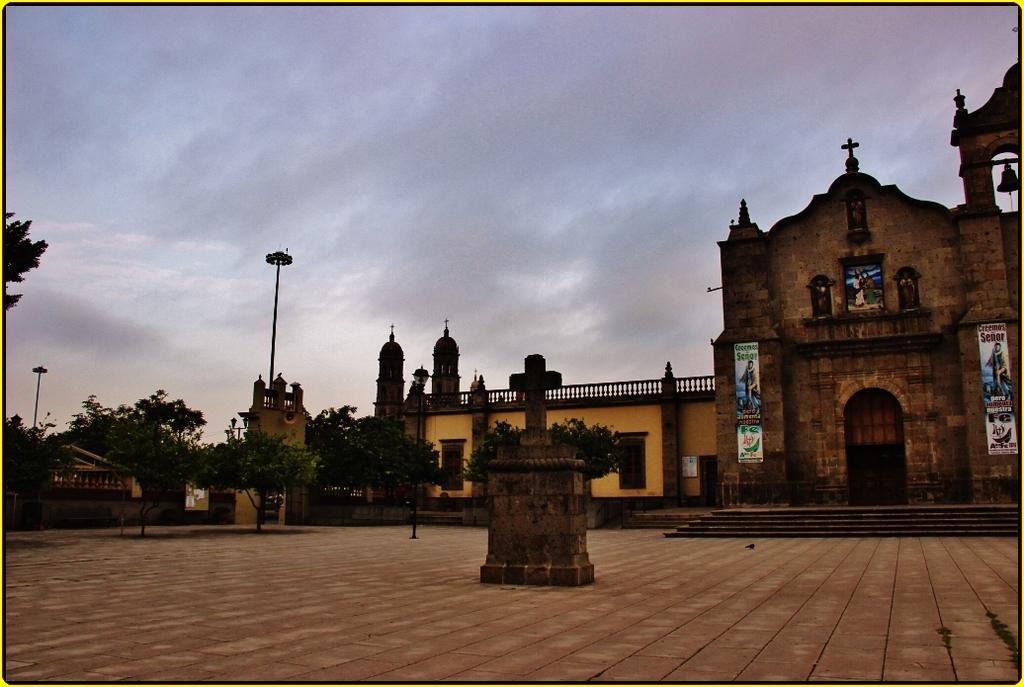How would you summarize this image in a sentence or two? In this image we can see there are buildings and pillars on the ground and there is the wall with posters and bell. And there are trees, light pole and the sky. 